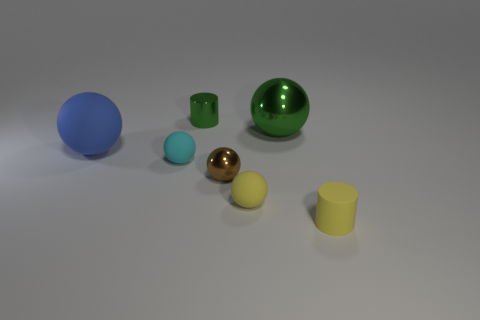There is a rubber object that is the same color as the small matte cylinder; what shape is it?
Your answer should be compact. Sphere. Do the cylinder behind the small cyan matte sphere and the big metal ball that is right of the blue rubber sphere have the same color?
Your response must be concise. Yes. What number of blue metal cubes are the same size as the brown object?
Give a very brief answer. 0. What number of objects are on the left side of the small matte object on the left side of the small metallic thing that is in front of the big green object?
Your answer should be very brief. 1. How many cylinders are both on the left side of the yellow sphere and right of the green shiny cylinder?
Make the answer very short. 0. Is there any other thing that has the same color as the small shiny cylinder?
Offer a very short reply. Yes. How many rubber objects are either blue objects or large cyan objects?
Provide a succinct answer. 1. What is the material of the tiny cylinder behind the thing in front of the small yellow matte thing that is on the left side of the big green sphere?
Ensure brevity in your answer.  Metal. The green thing behind the shiny sphere that is behind the big matte sphere is made of what material?
Offer a terse response. Metal. There is a cylinder that is behind the cyan rubber ball; is it the same size as the rubber sphere on the left side of the cyan matte thing?
Provide a succinct answer. No. 